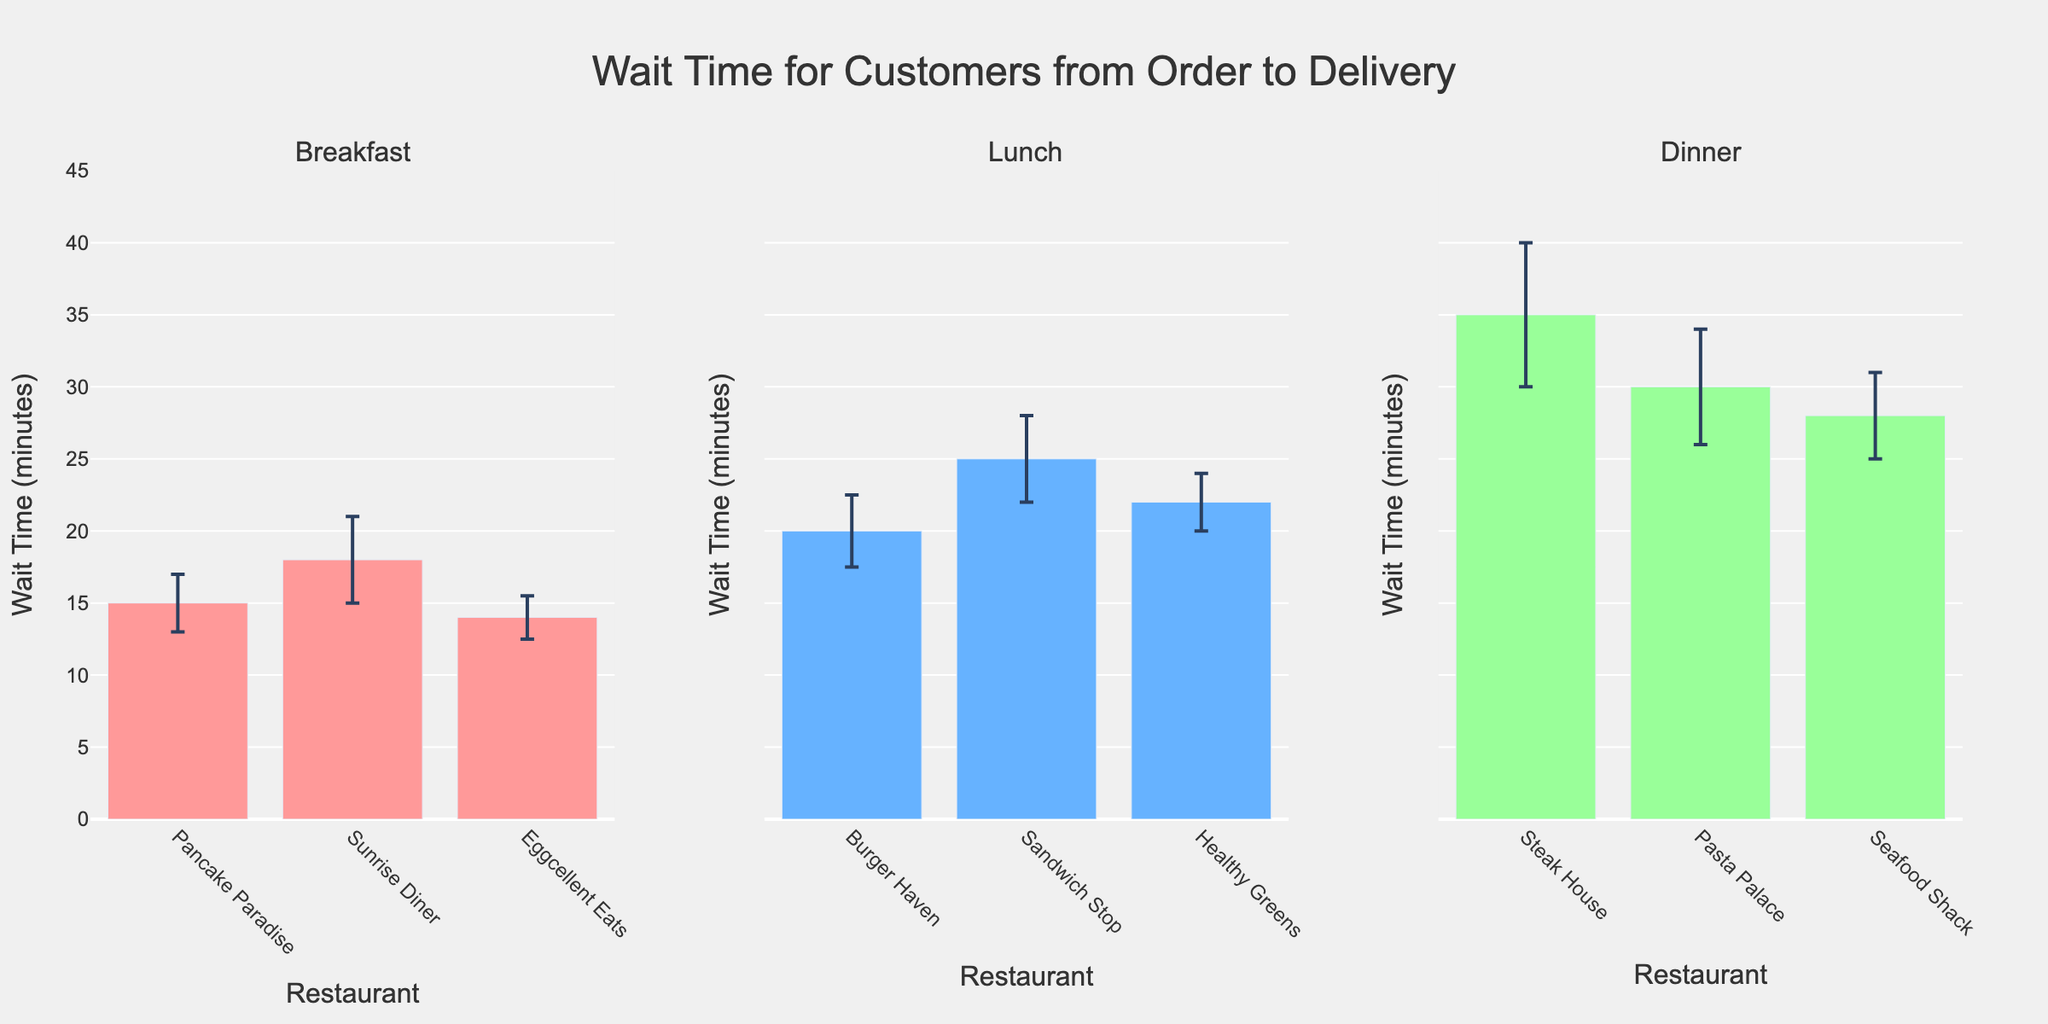What is the title of the figure? The title of the figure is displayed prominently at the top, summarizing the content of the visual in a few words. The plot title reads "Wait Time for Customers from Order to Delivery".
Answer: Wait Time for Customers from Order to Delivery Which restaurant had the shortest mean wait time for breakfast? To find the restaurant with the shortest mean wait time for breakfast, look at the bars in the Breakfast subplot and identify the one with the smallest height. Eggcellent Eats has the shortest bar in the Breakfast subplot.
Answer: Eggcellent Eats What is the mean wait time for Lunch at Burger Haven? Find Burger Haven in the Lunch subplot and read the height of its bar, which represents the mean wait time. The bar for Burger Haven in the Lunch subplot is at the 20-minute mark.
Answer: 20 minutes How many restaurants are displayed in the Dinner subplot? Count the number of bars in the Dinner subplot to determine the number of restaurants. There are three bars in the Dinner subplot representing Steak House, Pasta Palace, and Seafood Shack.
Answer: 3 Which meal time has the restaurant with the highest mean wait time? Compare the highest bars in each of the subplots for Breakfast, Lunch, and Dinner to find the tallest one. The Dinner subplot has the highest bar, which is Steak House.
Answer: Dinner Which restaurant has the highest standard deviation in wait times for Dinner, and what is its value? In the Dinner subplot, look at the error bars (vertical lines) and find the one with the largest extent. Steak House has the largest error bar, indicating the highest standard deviation, which is 5 minutes.
Answer: Steak House, 5 What is the difference in mean wait time between Sunrise Diner and Sandwich Stop? Find and subtract the mean wait time of Sunrise Diner in the Breakfast subplot from the mean wait time of Sandwich Stop in the Lunch subplot. Sunrise Diner has a mean wait time of 18 minutes, and Sandwich Stop has 25 minutes, so the difference is 25 - 18 = 7.
Answer: 7 minutes Which meal time has the lowest average wait time across its restaurants? Calculate the average wait time for each meal by averaging the mean wait times of restaurants within each subplot, and identify the meal time with the smallest value. For Breakfast: (15 + 18 + 14)/3 = 15.67, for Lunch: (20 + 25 + 22)/3 = 22.33, for Dinner: (35 + 30 + 28)/3 = 31. Thus, Breakfast has the lowest average.
Answer: Breakfast How do the wait times at the Steak House and Pasta Palace compare in terms of mean and variability? Compare the heights (mean wait times) and the lengths of error bars (standard deviations) of Steak House and Pasta Palace in the Dinner subplot. Steak House has a higher mean wait time (35 minutes) and higher standard deviation (5 minutes) compared to Pasta Palace's mean wait time (30 minutes) and standard deviation (4 minutes).
Answer: Steak House has higher mean and higher variability than Pasta Palace What can you infer about the consistency of service times at Eggcellent Eats compared to Healthy Greens? Compare the standard deviations (error bars) of Eggcellent Eats in the Breakfast subplot and Healthy Greens in the Lunch subplot. Eggcellent Eats has a shorter error bar (1.5 minutes), indicating more consistent service times compared to Healthy Greens with a longer error bar (2 minutes).
Answer: Eggcellent Eats has more consistent service times 